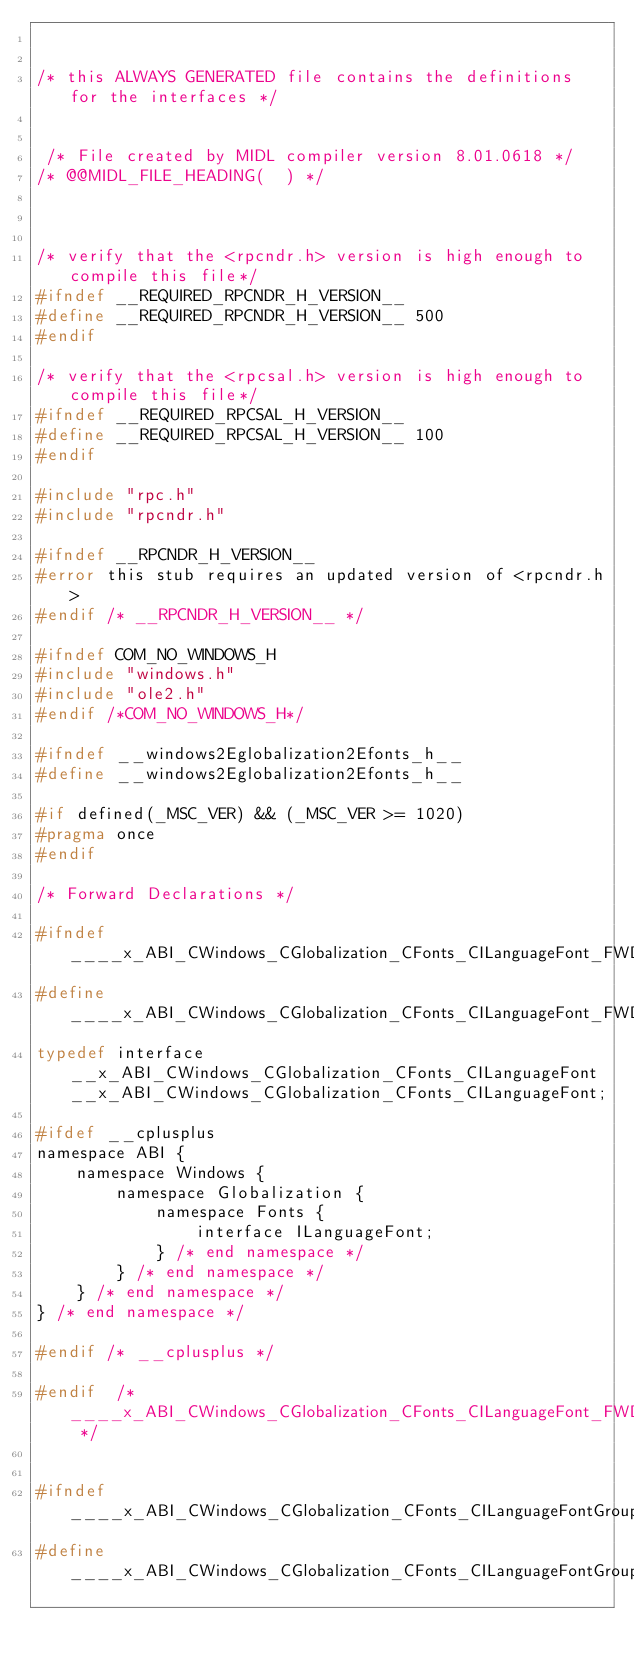Convert code to text. <code><loc_0><loc_0><loc_500><loc_500><_C_>

/* this ALWAYS GENERATED file contains the definitions for the interfaces */


 /* File created by MIDL compiler version 8.01.0618 */
/* @@MIDL_FILE_HEADING(  ) */



/* verify that the <rpcndr.h> version is high enough to compile this file*/
#ifndef __REQUIRED_RPCNDR_H_VERSION__
#define __REQUIRED_RPCNDR_H_VERSION__ 500
#endif

/* verify that the <rpcsal.h> version is high enough to compile this file*/
#ifndef __REQUIRED_RPCSAL_H_VERSION__
#define __REQUIRED_RPCSAL_H_VERSION__ 100
#endif

#include "rpc.h"
#include "rpcndr.h"

#ifndef __RPCNDR_H_VERSION__
#error this stub requires an updated version of <rpcndr.h>
#endif /* __RPCNDR_H_VERSION__ */

#ifndef COM_NO_WINDOWS_H
#include "windows.h"
#include "ole2.h"
#endif /*COM_NO_WINDOWS_H*/

#ifndef __windows2Eglobalization2Efonts_h__
#define __windows2Eglobalization2Efonts_h__

#if defined(_MSC_VER) && (_MSC_VER >= 1020)
#pragma once
#endif

/* Forward Declarations */ 

#ifndef ____x_ABI_CWindows_CGlobalization_CFonts_CILanguageFont_FWD_DEFINED__
#define ____x_ABI_CWindows_CGlobalization_CFonts_CILanguageFont_FWD_DEFINED__
typedef interface __x_ABI_CWindows_CGlobalization_CFonts_CILanguageFont __x_ABI_CWindows_CGlobalization_CFonts_CILanguageFont;

#ifdef __cplusplus
namespace ABI {
    namespace Windows {
        namespace Globalization {
            namespace Fonts {
                interface ILanguageFont;
            } /* end namespace */
        } /* end namespace */
    } /* end namespace */
} /* end namespace */

#endif /* __cplusplus */

#endif 	/* ____x_ABI_CWindows_CGlobalization_CFonts_CILanguageFont_FWD_DEFINED__ */


#ifndef ____x_ABI_CWindows_CGlobalization_CFonts_CILanguageFontGroup_FWD_DEFINED__
#define ____x_ABI_CWindows_CGlobalization_CFonts_CILanguageFontGroup_FWD_DEFINED__</code> 